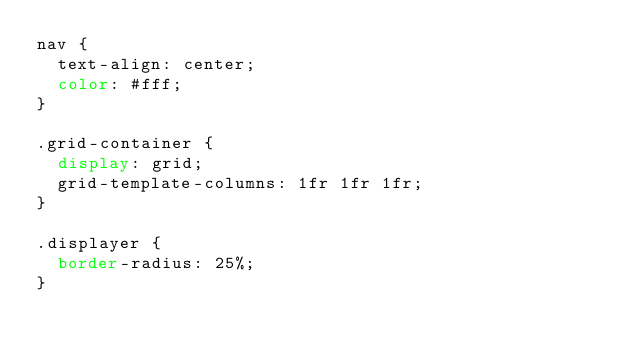Convert code to text. <code><loc_0><loc_0><loc_500><loc_500><_CSS_>nav {
  text-align: center;
  color: #fff;
}

.grid-container {
  display: grid;
  grid-template-columns: 1fr 1fr 1fr;
}

.displayer {
  border-radius: 25%;
}</code> 